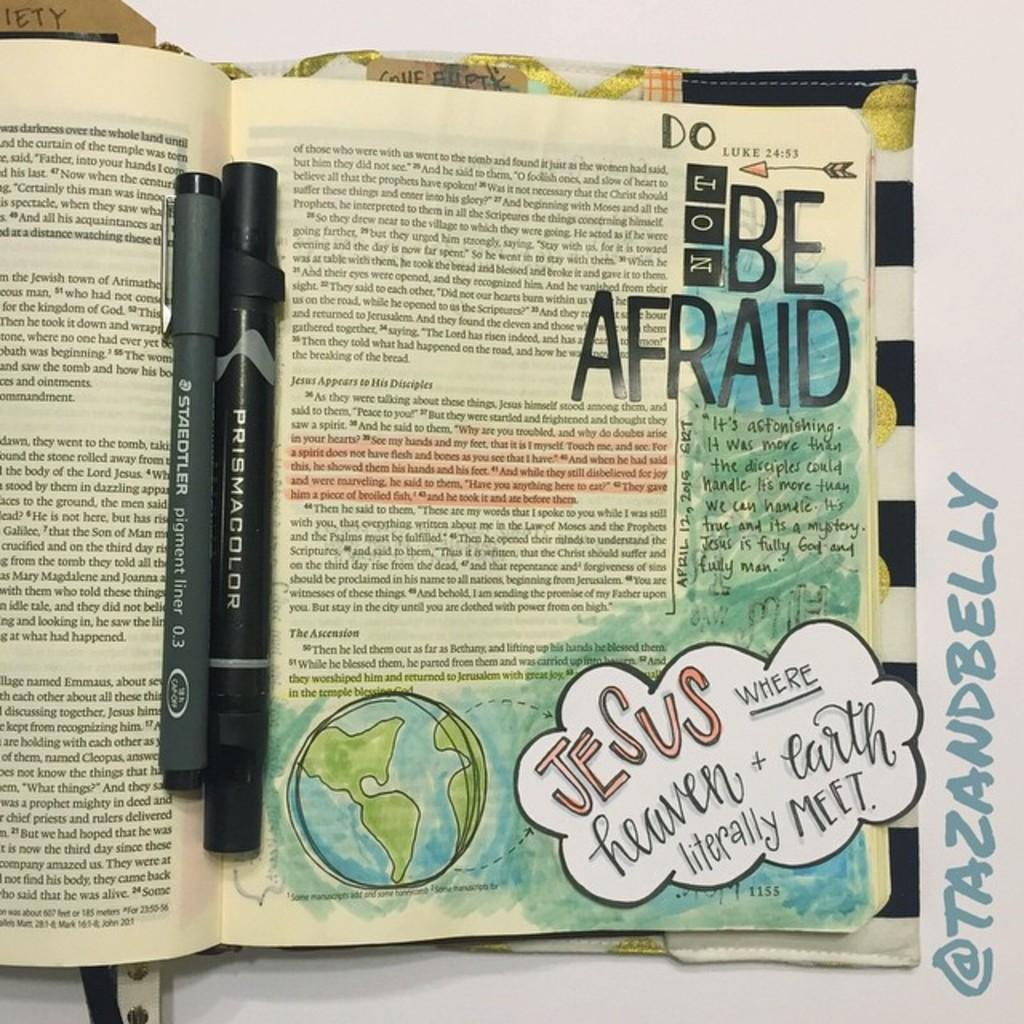<image>
Write a terse but informative summary of the picture. Somebody has written the words Do Not Be Afriad inside of a Bible 